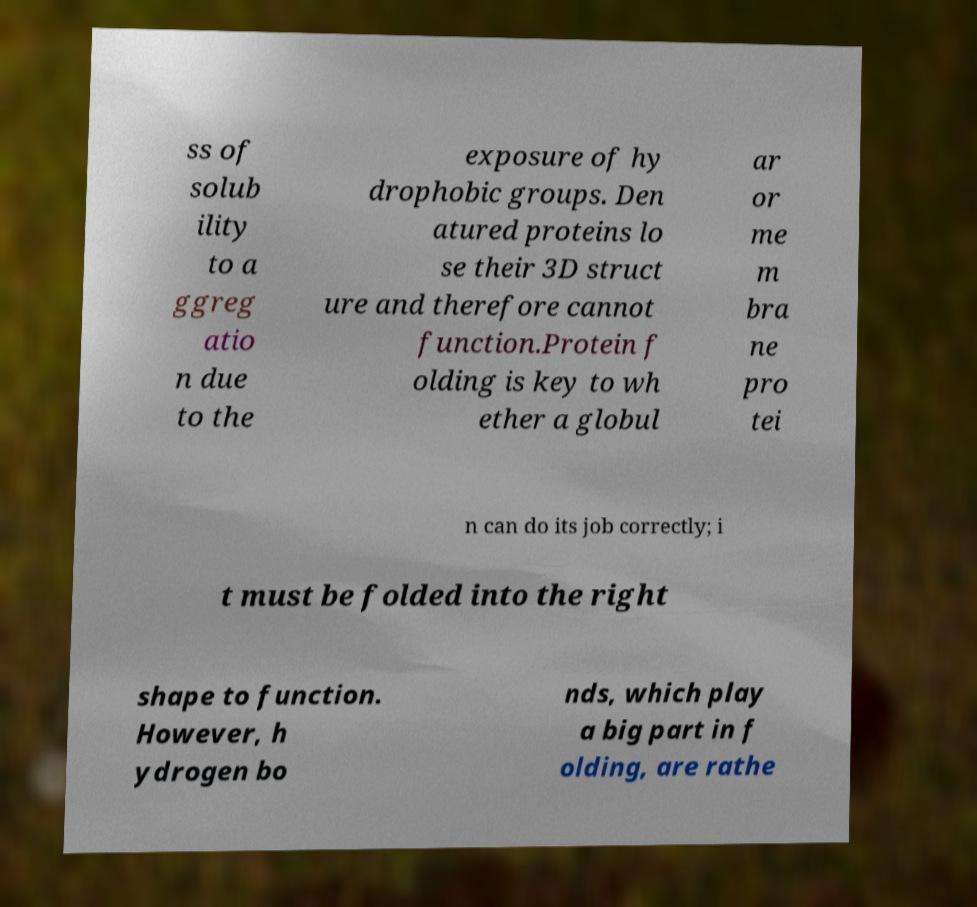Can you read and provide the text displayed in the image?This photo seems to have some interesting text. Can you extract and type it out for me? ss of solub ility to a ggreg atio n due to the exposure of hy drophobic groups. Den atured proteins lo se their 3D struct ure and therefore cannot function.Protein f olding is key to wh ether a globul ar or me m bra ne pro tei n can do its job correctly; i t must be folded into the right shape to function. However, h ydrogen bo nds, which play a big part in f olding, are rathe 